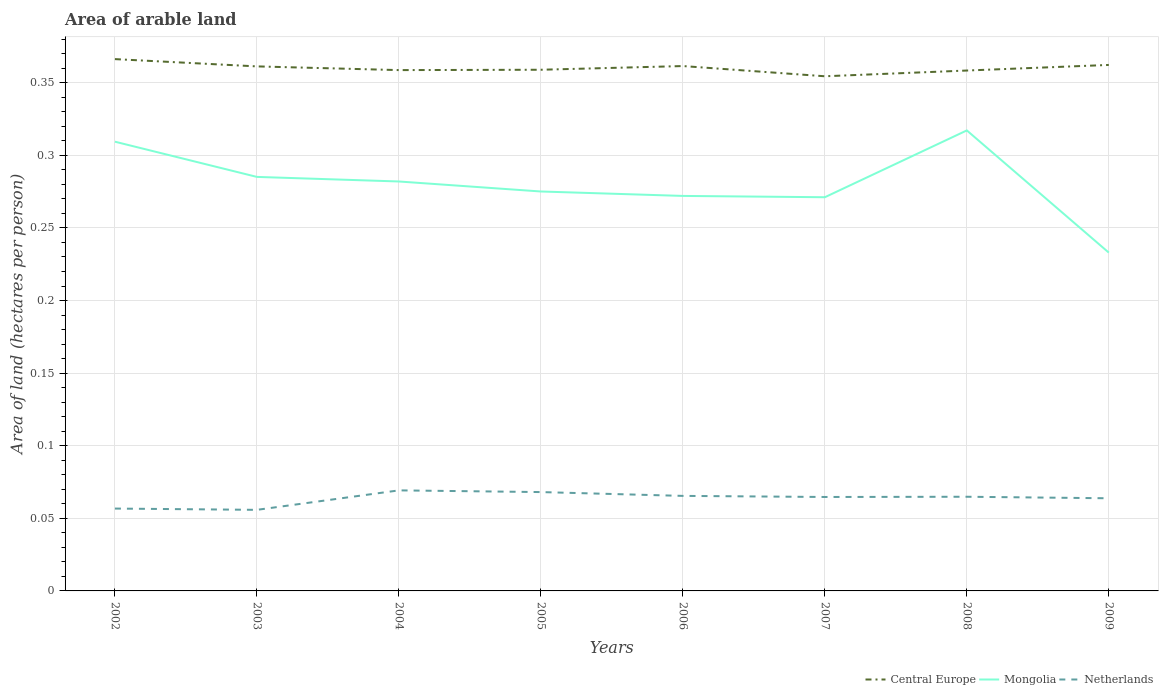How many different coloured lines are there?
Your answer should be very brief. 3. Does the line corresponding to Netherlands intersect with the line corresponding to Central Europe?
Ensure brevity in your answer.  No. Is the number of lines equal to the number of legend labels?
Offer a terse response. Yes. Across all years, what is the maximum total arable land in Central Europe?
Give a very brief answer. 0.35. What is the total total arable land in Netherlands in the graph?
Keep it short and to the point. 0. What is the difference between the highest and the second highest total arable land in Netherlands?
Ensure brevity in your answer.  0.01. What is the difference between the highest and the lowest total arable land in Central Europe?
Provide a short and direct response. 4. How many lines are there?
Offer a terse response. 3. How many years are there in the graph?
Your response must be concise. 8. Are the values on the major ticks of Y-axis written in scientific E-notation?
Give a very brief answer. No. Does the graph contain grids?
Give a very brief answer. Yes. Where does the legend appear in the graph?
Offer a terse response. Bottom right. How are the legend labels stacked?
Keep it short and to the point. Horizontal. What is the title of the graph?
Your answer should be compact. Area of arable land. What is the label or title of the X-axis?
Provide a short and direct response. Years. What is the label or title of the Y-axis?
Give a very brief answer. Area of land (hectares per person). What is the Area of land (hectares per person) of Central Europe in 2002?
Your answer should be compact. 0.37. What is the Area of land (hectares per person) of Mongolia in 2002?
Provide a short and direct response. 0.31. What is the Area of land (hectares per person) in Netherlands in 2002?
Provide a short and direct response. 0.06. What is the Area of land (hectares per person) of Central Europe in 2003?
Offer a very short reply. 0.36. What is the Area of land (hectares per person) of Mongolia in 2003?
Offer a very short reply. 0.29. What is the Area of land (hectares per person) in Netherlands in 2003?
Offer a very short reply. 0.06. What is the Area of land (hectares per person) in Central Europe in 2004?
Your answer should be very brief. 0.36. What is the Area of land (hectares per person) of Mongolia in 2004?
Offer a terse response. 0.28. What is the Area of land (hectares per person) of Netherlands in 2004?
Give a very brief answer. 0.07. What is the Area of land (hectares per person) in Central Europe in 2005?
Provide a short and direct response. 0.36. What is the Area of land (hectares per person) of Mongolia in 2005?
Offer a very short reply. 0.28. What is the Area of land (hectares per person) in Netherlands in 2005?
Offer a very short reply. 0.07. What is the Area of land (hectares per person) in Central Europe in 2006?
Make the answer very short. 0.36. What is the Area of land (hectares per person) of Mongolia in 2006?
Give a very brief answer. 0.27. What is the Area of land (hectares per person) of Netherlands in 2006?
Ensure brevity in your answer.  0.07. What is the Area of land (hectares per person) in Central Europe in 2007?
Offer a terse response. 0.35. What is the Area of land (hectares per person) in Mongolia in 2007?
Give a very brief answer. 0.27. What is the Area of land (hectares per person) of Netherlands in 2007?
Offer a terse response. 0.06. What is the Area of land (hectares per person) of Central Europe in 2008?
Make the answer very short. 0.36. What is the Area of land (hectares per person) of Mongolia in 2008?
Your response must be concise. 0.32. What is the Area of land (hectares per person) in Netherlands in 2008?
Keep it short and to the point. 0.06. What is the Area of land (hectares per person) in Central Europe in 2009?
Your response must be concise. 0.36. What is the Area of land (hectares per person) of Mongolia in 2009?
Your response must be concise. 0.23. What is the Area of land (hectares per person) of Netherlands in 2009?
Give a very brief answer. 0.06. Across all years, what is the maximum Area of land (hectares per person) in Central Europe?
Keep it short and to the point. 0.37. Across all years, what is the maximum Area of land (hectares per person) in Mongolia?
Offer a terse response. 0.32. Across all years, what is the maximum Area of land (hectares per person) in Netherlands?
Provide a succinct answer. 0.07. Across all years, what is the minimum Area of land (hectares per person) in Central Europe?
Your answer should be very brief. 0.35. Across all years, what is the minimum Area of land (hectares per person) of Mongolia?
Ensure brevity in your answer.  0.23. Across all years, what is the minimum Area of land (hectares per person) of Netherlands?
Make the answer very short. 0.06. What is the total Area of land (hectares per person) of Central Europe in the graph?
Provide a succinct answer. 2.88. What is the total Area of land (hectares per person) in Mongolia in the graph?
Your answer should be very brief. 2.24. What is the total Area of land (hectares per person) of Netherlands in the graph?
Your answer should be compact. 0.51. What is the difference between the Area of land (hectares per person) in Central Europe in 2002 and that in 2003?
Offer a terse response. 0.01. What is the difference between the Area of land (hectares per person) of Mongolia in 2002 and that in 2003?
Offer a terse response. 0.02. What is the difference between the Area of land (hectares per person) of Netherlands in 2002 and that in 2003?
Your response must be concise. 0. What is the difference between the Area of land (hectares per person) of Central Europe in 2002 and that in 2004?
Give a very brief answer. 0.01. What is the difference between the Area of land (hectares per person) of Mongolia in 2002 and that in 2004?
Offer a very short reply. 0.03. What is the difference between the Area of land (hectares per person) of Netherlands in 2002 and that in 2004?
Ensure brevity in your answer.  -0.01. What is the difference between the Area of land (hectares per person) of Central Europe in 2002 and that in 2005?
Your answer should be compact. 0.01. What is the difference between the Area of land (hectares per person) in Mongolia in 2002 and that in 2005?
Provide a short and direct response. 0.03. What is the difference between the Area of land (hectares per person) of Netherlands in 2002 and that in 2005?
Make the answer very short. -0.01. What is the difference between the Area of land (hectares per person) in Central Europe in 2002 and that in 2006?
Ensure brevity in your answer.  0. What is the difference between the Area of land (hectares per person) of Mongolia in 2002 and that in 2006?
Your answer should be very brief. 0.04. What is the difference between the Area of land (hectares per person) in Netherlands in 2002 and that in 2006?
Give a very brief answer. -0.01. What is the difference between the Area of land (hectares per person) in Central Europe in 2002 and that in 2007?
Your answer should be compact. 0.01. What is the difference between the Area of land (hectares per person) of Mongolia in 2002 and that in 2007?
Provide a succinct answer. 0.04. What is the difference between the Area of land (hectares per person) in Netherlands in 2002 and that in 2007?
Your answer should be very brief. -0.01. What is the difference between the Area of land (hectares per person) of Central Europe in 2002 and that in 2008?
Your response must be concise. 0.01. What is the difference between the Area of land (hectares per person) in Mongolia in 2002 and that in 2008?
Offer a very short reply. -0.01. What is the difference between the Area of land (hectares per person) in Netherlands in 2002 and that in 2008?
Offer a very short reply. -0.01. What is the difference between the Area of land (hectares per person) of Central Europe in 2002 and that in 2009?
Your answer should be very brief. 0. What is the difference between the Area of land (hectares per person) in Mongolia in 2002 and that in 2009?
Your answer should be very brief. 0.08. What is the difference between the Area of land (hectares per person) in Netherlands in 2002 and that in 2009?
Make the answer very short. -0.01. What is the difference between the Area of land (hectares per person) in Central Europe in 2003 and that in 2004?
Your answer should be very brief. 0. What is the difference between the Area of land (hectares per person) in Mongolia in 2003 and that in 2004?
Give a very brief answer. 0. What is the difference between the Area of land (hectares per person) of Netherlands in 2003 and that in 2004?
Offer a very short reply. -0.01. What is the difference between the Area of land (hectares per person) in Central Europe in 2003 and that in 2005?
Offer a very short reply. 0. What is the difference between the Area of land (hectares per person) in Mongolia in 2003 and that in 2005?
Give a very brief answer. 0.01. What is the difference between the Area of land (hectares per person) in Netherlands in 2003 and that in 2005?
Give a very brief answer. -0.01. What is the difference between the Area of land (hectares per person) in Central Europe in 2003 and that in 2006?
Offer a terse response. -0. What is the difference between the Area of land (hectares per person) in Mongolia in 2003 and that in 2006?
Your answer should be very brief. 0.01. What is the difference between the Area of land (hectares per person) of Netherlands in 2003 and that in 2006?
Provide a short and direct response. -0.01. What is the difference between the Area of land (hectares per person) of Central Europe in 2003 and that in 2007?
Make the answer very short. 0.01. What is the difference between the Area of land (hectares per person) of Mongolia in 2003 and that in 2007?
Make the answer very short. 0.01. What is the difference between the Area of land (hectares per person) in Netherlands in 2003 and that in 2007?
Provide a short and direct response. -0.01. What is the difference between the Area of land (hectares per person) of Central Europe in 2003 and that in 2008?
Provide a succinct answer. 0. What is the difference between the Area of land (hectares per person) in Mongolia in 2003 and that in 2008?
Your response must be concise. -0.03. What is the difference between the Area of land (hectares per person) of Netherlands in 2003 and that in 2008?
Give a very brief answer. -0.01. What is the difference between the Area of land (hectares per person) in Central Europe in 2003 and that in 2009?
Offer a terse response. -0. What is the difference between the Area of land (hectares per person) in Mongolia in 2003 and that in 2009?
Give a very brief answer. 0.05. What is the difference between the Area of land (hectares per person) in Netherlands in 2003 and that in 2009?
Provide a succinct answer. -0.01. What is the difference between the Area of land (hectares per person) in Central Europe in 2004 and that in 2005?
Provide a short and direct response. -0. What is the difference between the Area of land (hectares per person) of Mongolia in 2004 and that in 2005?
Give a very brief answer. 0.01. What is the difference between the Area of land (hectares per person) in Netherlands in 2004 and that in 2005?
Provide a short and direct response. 0. What is the difference between the Area of land (hectares per person) in Central Europe in 2004 and that in 2006?
Your response must be concise. -0. What is the difference between the Area of land (hectares per person) of Mongolia in 2004 and that in 2006?
Provide a short and direct response. 0.01. What is the difference between the Area of land (hectares per person) of Netherlands in 2004 and that in 2006?
Keep it short and to the point. 0. What is the difference between the Area of land (hectares per person) of Central Europe in 2004 and that in 2007?
Your answer should be compact. 0. What is the difference between the Area of land (hectares per person) in Mongolia in 2004 and that in 2007?
Your response must be concise. 0.01. What is the difference between the Area of land (hectares per person) of Netherlands in 2004 and that in 2007?
Your answer should be compact. 0. What is the difference between the Area of land (hectares per person) of Central Europe in 2004 and that in 2008?
Offer a terse response. 0. What is the difference between the Area of land (hectares per person) in Mongolia in 2004 and that in 2008?
Give a very brief answer. -0.04. What is the difference between the Area of land (hectares per person) of Netherlands in 2004 and that in 2008?
Your response must be concise. 0. What is the difference between the Area of land (hectares per person) of Central Europe in 2004 and that in 2009?
Your response must be concise. -0. What is the difference between the Area of land (hectares per person) in Mongolia in 2004 and that in 2009?
Offer a very short reply. 0.05. What is the difference between the Area of land (hectares per person) in Netherlands in 2004 and that in 2009?
Your answer should be compact. 0.01. What is the difference between the Area of land (hectares per person) in Central Europe in 2005 and that in 2006?
Ensure brevity in your answer.  -0. What is the difference between the Area of land (hectares per person) in Mongolia in 2005 and that in 2006?
Provide a succinct answer. 0. What is the difference between the Area of land (hectares per person) of Netherlands in 2005 and that in 2006?
Keep it short and to the point. 0. What is the difference between the Area of land (hectares per person) in Central Europe in 2005 and that in 2007?
Your response must be concise. 0. What is the difference between the Area of land (hectares per person) of Mongolia in 2005 and that in 2007?
Keep it short and to the point. 0. What is the difference between the Area of land (hectares per person) in Netherlands in 2005 and that in 2007?
Give a very brief answer. 0. What is the difference between the Area of land (hectares per person) of Mongolia in 2005 and that in 2008?
Keep it short and to the point. -0.04. What is the difference between the Area of land (hectares per person) in Netherlands in 2005 and that in 2008?
Your response must be concise. 0. What is the difference between the Area of land (hectares per person) of Central Europe in 2005 and that in 2009?
Offer a terse response. -0. What is the difference between the Area of land (hectares per person) of Mongolia in 2005 and that in 2009?
Offer a terse response. 0.04. What is the difference between the Area of land (hectares per person) of Netherlands in 2005 and that in 2009?
Give a very brief answer. 0. What is the difference between the Area of land (hectares per person) in Central Europe in 2006 and that in 2007?
Give a very brief answer. 0.01. What is the difference between the Area of land (hectares per person) of Mongolia in 2006 and that in 2007?
Provide a short and direct response. 0. What is the difference between the Area of land (hectares per person) in Netherlands in 2006 and that in 2007?
Your answer should be compact. 0. What is the difference between the Area of land (hectares per person) of Central Europe in 2006 and that in 2008?
Give a very brief answer. 0. What is the difference between the Area of land (hectares per person) of Mongolia in 2006 and that in 2008?
Provide a short and direct response. -0.05. What is the difference between the Area of land (hectares per person) of Netherlands in 2006 and that in 2008?
Provide a succinct answer. 0. What is the difference between the Area of land (hectares per person) of Central Europe in 2006 and that in 2009?
Keep it short and to the point. -0. What is the difference between the Area of land (hectares per person) in Mongolia in 2006 and that in 2009?
Ensure brevity in your answer.  0.04. What is the difference between the Area of land (hectares per person) in Netherlands in 2006 and that in 2009?
Give a very brief answer. 0. What is the difference between the Area of land (hectares per person) of Central Europe in 2007 and that in 2008?
Your answer should be compact. -0. What is the difference between the Area of land (hectares per person) of Mongolia in 2007 and that in 2008?
Ensure brevity in your answer.  -0.05. What is the difference between the Area of land (hectares per person) in Netherlands in 2007 and that in 2008?
Keep it short and to the point. -0. What is the difference between the Area of land (hectares per person) of Central Europe in 2007 and that in 2009?
Offer a very short reply. -0.01. What is the difference between the Area of land (hectares per person) of Mongolia in 2007 and that in 2009?
Keep it short and to the point. 0.04. What is the difference between the Area of land (hectares per person) of Netherlands in 2007 and that in 2009?
Your answer should be compact. 0. What is the difference between the Area of land (hectares per person) in Central Europe in 2008 and that in 2009?
Your answer should be compact. -0. What is the difference between the Area of land (hectares per person) in Mongolia in 2008 and that in 2009?
Give a very brief answer. 0.08. What is the difference between the Area of land (hectares per person) in Netherlands in 2008 and that in 2009?
Offer a very short reply. 0. What is the difference between the Area of land (hectares per person) in Central Europe in 2002 and the Area of land (hectares per person) in Mongolia in 2003?
Provide a short and direct response. 0.08. What is the difference between the Area of land (hectares per person) of Central Europe in 2002 and the Area of land (hectares per person) of Netherlands in 2003?
Offer a terse response. 0.31. What is the difference between the Area of land (hectares per person) in Mongolia in 2002 and the Area of land (hectares per person) in Netherlands in 2003?
Your answer should be compact. 0.25. What is the difference between the Area of land (hectares per person) in Central Europe in 2002 and the Area of land (hectares per person) in Mongolia in 2004?
Make the answer very short. 0.08. What is the difference between the Area of land (hectares per person) of Central Europe in 2002 and the Area of land (hectares per person) of Netherlands in 2004?
Ensure brevity in your answer.  0.3. What is the difference between the Area of land (hectares per person) in Mongolia in 2002 and the Area of land (hectares per person) in Netherlands in 2004?
Keep it short and to the point. 0.24. What is the difference between the Area of land (hectares per person) in Central Europe in 2002 and the Area of land (hectares per person) in Mongolia in 2005?
Your response must be concise. 0.09. What is the difference between the Area of land (hectares per person) of Central Europe in 2002 and the Area of land (hectares per person) of Netherlands in 2005?
Your answer should be compact. 0.3. What is the difference between the Area of land (hectares per person) of Mongolia in 2002 and the Area of land (hectares per person) of Netherlands in 2005?
Provide a succinct answer. 0.24. What is the difference between the Area of land (hectares per person) in Central Europe in 2002 and the Area of land (hectares per person) in Mongolia in 2006?
Offer a very short reply. 0.09. What is the difference between the Area of land (hectares per person) in Central Europe in 2002 and the Area of land (hectares per person) in Netherlands in 2006?
Provide a succinct answer. 0.3. What is the difference between the Area of land (hectares per person) of Mongolia in 2002 and the Area of land (hectares per person) of Netherlands in 2006?
Offer a terse response. 0.24. What is the difference between the Area of land (hectares per person) of Central Europe in 2002 and the Area of land (hectares per person) of Mongolia in 2007?
Offer a terse response. 0.1. What is the difference between the Area of land (hectares per person) in Central Europe in 2002 and the Area of land (hectares per person) in Netherlands in 2007?
Offer a very short reply. 0.3. What is the difference between the Area of land (hectares per person) in Mongolia in 2002 and the Area of land (hectares per person) in Netherlands in 2007?
Ensure brevity in your answer.  0.24. What is the difference between the Area of land (hectares per person) of Central Europe in 2002 and the Area of land (hectares per person) of Mongolia in 2008?
Keep it short and to the point. 0.05. What is the difference between the Area of land (hectares per person) in Central Europe in 2002 and the Area of land (hectares per person) in Netherlands in 2008?
Keep it short and to the point. 0.3. What is the difference between the Area of land (hectares per person) of Mongolia in 2002 and the Area of land (hectares per person) of Netherlands in 2008?
Offer a very short reply. 0.24. What is the difference between the Area of land (hectares per person) in Central Europe in 2002 and the Area of land (hectares per person) in Mongolia in 2009?
Offer a terse response. 0.13. What is the difference between the Area of land (hectares per person) in Central Europe in 2002 and the Area of land (hectares per person) in Netherlands in 2009?
Keep it short and to the point. 0.3. What is the difference between the Area of land (hectares per person) in Mongolia in 2002 and the Area of land (hectares per person) in Netherlands in 2009?
Provide a succinct answer. 0.25. What is the difference between the Area of land (hectares per person) in Central Europe in 2003 and the Area of land (hectares per person) in Mongolia in 2004?
Give a very brief answer. 0.08. What is the difference between the Area of land (hectares per person) of Central Europe in 2003 and the Area of land (hectares per person) of Netherlands in 2004?
Offer a terse response. 0.29. What is the difference between the Area of land (hectares per person) of Mongolia in 2003 and the Area of land (hectares per person) of Netherlands in 2004?
Offer a terse response. 0.22. What is the difference between the Area of land (hectares per person) in Central Europe in 2003 and the Area of land (hectares per person) in Mongolia in 2005?
Keep it short and to the point. 0.09. What is the difference between the Area of land (hectares per person) in Central Europe in 2003 and the Area of land (hectares per person) in Netherlands in 2005?
Keep it short and to the point. 0.29. What is the difference between the Area of land (hectares per person) in Mongolia in 2003 and the Area of land (hectares per person) in Netherlands in 2005?
Make the answer very short. 0.22. What is the difference between the Area of land (hectares per person) of Central Europe in 2003 and the Area of land (hectares per person) of Mongolia in 2006?
Your answer should be compact. 0.09. What is the difference between the Area of land (hectares per person) of Central Europe in 2003 and the Area of land (hectares per person) of Netherlands in 2006?
Keep it short and to the point. 0.3. What is the difference between the Area of land (hectares per person) of Mongolia in 2003 and the Area of land (hectares per person) of Netherlands in 2006?
Your answer should be very brief. 0.22. What is the difference between the Area of land (hectares per person) of Central Europe in 2003 and the Area of land (hectares per person) of Mongolia in 2007?
Your answer should be compact. 0.09. What is the difference between the Area of land (hectares per person) of Central Europe in 2003 and the Area of land (hectares per person) of Netherlands in 2007?
Ensure brevity in your answer.  0.3. What is the difference between the Area of land (hectares per person) of Mongolia in 2003 and the Area of land (hectares per person) of Netherlands in 2007?
Your answer should be compact. 0.22. What is the difference between the Area of land (hectares per person) in Central Europe in 2003 and the Area of land (hectares per person) in Mongolia in 2008?
Offer a very short reply. 0.04. What is the difference between the Area of land (hectares per person) in Central Europe in 2003 and the Area of land (hectares per person) in Netherlands in 2008?
Provide a succinct answer. 0.3. What is the difference between the Area of land (hectares per person) in Mongolia in 2003 and the Area of land (hectares per person) in Netherlands in 2008?
Give a very brief answer. 0.22. What is the difference between the Area of land (hectares per person) of Central Europe in 2003 and the Area of land (hectares per person) of Mongolia in 2009?
Your answer should be compact. 0.13. What is the difference between the Area of land (hectares per person) of Central Europe in 2003 and the Area of land (hectares per person) of Netherlands in 2009?
Give a very brief answer. 0.3. What is the difference between the Area of land (hectares per person) in Mongolia in 2003 and the Area of land (hectares per person) in Netherlands in 2009?
Give a very brief answer. 0.22. What is the difference between the Area of land (hectares per person) in Central Europe in 2004 and the Area of land (hectares per person) in Mongolia in 2005?
Provide a succinct answer. 0.08. What is the difference between the Area of land (hectares per person) of Central Europe in 2004 and the Area of land (hectares per person) of Netherlands in 2005?
Make the answer very short. 0.29. What is the difference between the Area of land (hectares per person) of Mongolia in 2004 and the Area of land (hectares per person) of Netherlands in 2005?
Offer a very short reply. 0.21. What is the difference between the Area of land (hectares per person) in Central Europe in 2004 and the Area of land (hectares per person) in Mongolia in 2006?
Offer a very short reply. 0.09. What is the difference between the Area of land (hectares per person) of Central Europe in 2004 and the Area of land (hectares per person) of Netherlands in 2006?
Provide a succinct answer. 0.29. What is the difference between the Area of land (hectares per person) in Mongolia in 2004 and the Area of land (hectares per person) in Netherlands in 2006?
Provide a succinct answer. 0.22. What is the difference between the Area of land (hectares per person) in Central Europe in 2004 and the Area of land (hectares per person) in Mongolia in 2007?
Keep it short and to the point. 0.09. What is the difference between the Area of land (hectares per person) in Central Europe in 2004 and the Area of land (hectares per person) in Netherlands in 2007?
Ensure brevity in your answer.  0.29. What is the difference between the Area of land (hectares per person) in Mongolia in 2004 and the Area of land (hectares per person) in Netherlands in 2007?
Ensure brevity in your answer.  0.22. What is the difference between the Area of land (hectares per person) in Central Europe in 2004 and the Area of land (hectares per person) in Mongolia in 2008?
Provide a short and direct response. 0.04. What is the difference between the Area of land (hectares per person) in Central Europe in 2004 and the Area of land (hectares per person) in Netherlands in 2008?
Keep it short and to the point. 0.29. What is the difference between the Area of land (hectares per person) of Mongolia in 2004 and the Area of land (hectares per person) of Netherlands in 2008?
Make the answer very short. 0.22. What is the difference between the Area of land (hectares per person) in Central Europe in 2004 and the Area of land (hectares per person) in Mongolia in 2009?
Give a very brief answer. 0.13. What is the difference between the Area of land (hectares per person) in Central Europe in 2004 and the Area of land (hectares per person) in Netherlands in 2009?
Provide a short and direct response. 0.29. What is the difference between the Area of land (hectares per person) of Mongolia in 2004 and the Area of land (hectares per person) of Netherlands in 2009?
Your answer should be compact. 0.22. What is the difference between the Area of land (hectares per person) in Central Europe in 2005 and the Area of land (hectares per person) in Mongolia in 2006?
Give a very brief answer. 0.09. What is the difference between the Area of land (hectares per person) of Central Europe in 2005 and the Area of land (hectares per person) of Netherlands in 2006?
Make the answer very short. 0.29. What is the difference between the Area of land (hectares per person) in Mongolia in 2005 and the Area of land (hectares per person) in Netherlands in 2006?
Make the answer very short. 0.21. What is the difference between the Area of land (hectares per person) in Central Europe in 2005 and the Area of land (hectares per person) in Mongolia in 2007?
Your answer should be very brief. 0.09. What is the difference between the Area of land (hectares per person) of Central Europe in 2005 and the Area of land (hectares per person) of Netherlands in 2007?
Your answer should be very brief. 0.29. What is the difference between the Area of land (hectares per person) of Mongolia in 2005 and the Area of land (hectares per person) of Netherlands in 2007?
Offer a very short reply. 0.21. What is the difference between the Area of land (hectares per person) of Central Europe in 2005 and the Area of land (hectares per person) of Mongolia in 2008?
Your answer should be very brief. 0.04. What is the difference between the Area of land (hectares per person) in Central Europe in 2005 and the Area of land (hectares per person) in Netherlands in 2008?
Provide a short and direct response. 0.29. What is the difference between the Area of land (hectares per person) of Mongolia in 2005 and the Area of land (hectares per person) of Netherlands in 2008?
Provide a short and direct response. 0.21. What is the difference between the Area of land (hectares per person) in Central Europe in 2005 and the Area of land (hectares per person) in Mongolia in 2009?
Offer a terse response. 0.13. What is the difference between the Area of land (hectares per person) of Central Europe in 2005 and the Area of land (hectares per person) of Netherlands in 2009?
Offer a very short reply. 0.3. What is the difference between the Area of land (hectares per person) in Mongolia in 2005 and the Area of land (hectares per person) in Netherlands in 2009?
Your answer should be very brief. 0.21. What is the difference between the Area of land (hectares per person) of Central Europe in 2006 and the Area of land (hectares per person) of Mongolia in 2007?
Provide a short and direct response. 0.09. What is the difference between the Area of land (hectares per person) of Central Europe in 2006 and the Area of land (hectares per person) of Netherlands in 2007?
Your response must be concise. 0.3. What is the difference between the Area of land (hectares per person) of Mongolia in 2006 and the Area of land (hectares per person) of Netherlands in 2007?
Give a very brief answer. 0.21. What is the difference between the Area of land (hectares per person) in Central Europe in 2006 and the Area of land (hectares per person) in Mongolia in 2008?
Your answer should be compact. 0.04. What is the difference between the Area of land (hectares per person) in Central Europe in 2006 and the Area of land (hectares per person) in Netherlands in 2008?
Provide a short and direct response. 0.3. What is the difference between the Area of land (hectares per person) of Mongolia in 2006 and the Area of land (hectares per person) of Netherlands in 2008?
Provide a succinct answer. 0.21. What is the difference between the Area of land (hectares per person) in Central Europe in 2006 and the Area of land (hectares per person) in Mongolia in 2009?
Provide a short and direct response. 0.13. What is the difference between the Area of land (hectares per person) of Central Europe in 2006 and the Area of land (hectares per person) of Netherlands in 2009?
Your answer should be compact. 0.3. What is the difference between the Area of land (hectares per person) of Mongolia in 2006 and the Area of land (hectares per person) of Netherlands in 2009?
Provide a succinct answer. 0.21. What is the difference between the Area of land (hectares per person) in Central Europe in 2007 and the Area of land (hectares per person) in Mongolia in 2008?
Provide a succinct answer. 0.04. What is the difference between the Area of land (hectares per person) in Central Europe in 2007 and the Area of land (hectares per person) in Netherlands in 2008?
Give a very brief answer. 0.29. What is the difference between the Area of land (hectares per person) of Mongolia in 2007 and the Area of land (hectares per person) of Netherlands in 2008?
Your answer should be very brief. 0.21. What is the difference between the Area of land (hectares per person) of Central Europe in 2007 and the Area of land (hectares per person) of Mongolia in 2009?
Keep it short and to the point. 0.12. What is the difference between the Area of land (hectares per person) in Central Europe in 2007 and the Area of land (hectares per person) in Netherlands in 2009?
Ensure brevity in your answer.  0.29. What is the difference between the Area of land (hectares per person) of Mongolia in 2007 and the Area of land (hectares per person) of Netherlands in 2009?
Your answer should be very brief. 0.21. What is the difference between the Area of land (hectares per person) in Central Europe in 2008 and the Area of land (hectares per person) in Mongolia in 2009?
Ensure brevity in your answer.  0.13. What is the difference between the Area of land (hectares per person) of Central Europe in 2008 and the Area of land (hectares per person) of Netherlands in 2009?
Your answer should be very brief. 0.29. What is the difference between the Area of land (hectares per person) of Mongolia in 2008 and the Area of land (hectares per person) of Netherlands in 2009?
Offer a terse response. 0.25. What is the average Area of land (hectares per person) of Central Europe per year?
Your answer should be very brief. 0.36. What is the average Area of land (hectares per person) of Mongolia per year?
Your response must be concise. 0.28. What is the average Area of land (hectares per person) in Netherlands per year?
Keep it short and to the point. 0.06. In the year 2002, what is the difference between the Area of land (hectares per person) of Central Europe and Area of land (hectares per person) of Mongolia?
Your answer should be very brief. 0.06. In the year 2002, what is the difference between the Area of land (hectares per person) of Central Europe and Area of land (hectares per person) of Netherlands?
Make the answer very short. 0.31. In the year 2002, what is the difference between the Area of land (hectares per person) in Mongolia and Area of land (hectares per person) in Netherlands?
Make the answer very short. 0.25. In the year 2003, what is the difference between the Area of land (hectares per person) in Central Europe and Area of land (hectares per person) in Mongolia?
Offer a very short reply. 0.08. In the year 2003, what is the difference between the Area of land (hectares per person) in Central Europe and Area of land (hectares per person) in Netherlands?
Ensure brevity in your answer.  0.31. In the year 2003, what is the difference between the Area of land (hectares per person) of Mongolia and Area of land (hectares per person) of Netherlands?
Make the answer very short. 0.23. In the year 2004, what is the difference between the Area of land (hectares per person) of Central Europe and Area of land (hectares per person) of Mongolia?
Provide a succinct answer. 0.08. In the year 2004, what is the difference between the Area of land (hectares per person) of Central Europe and Area of land (hectares per person) of Netherlands?
Your answer should be very brief. 0.29. In the year 2004, what is the difference between the Area of land (hectares per person) of Mongolia and Area of land (hectares per person) of Netherlands?
Ensure brevity in your answer.  0.21. In the year 2005, what is the difference between the Area of land (hectares per person) of Central Europe and Area of land (hectares per person) of Mongolia?
Keep it short and to the point. 0.08. In the year 2005, what is the difference between the Area of land (hectares per person) of Central Europe and Area of land (hectares per person) of Netherlands?
Your response must be concise. 0.29. In the year 2005, what is the difference between the Area of land (hectares per person) in Mongolia and Area of land (hectares per person) in Netherlands?
Your answer should be compact. 0.21. In the year 2006, what is the difference between the Area of land (hectares per person) of Central Europe and Area of land (hectares per person) of Mongolia?
Offer a very short reply. 0.09. In the year 2006, what is the difference between the Area of land (hectares per person) in Central Europe and Area of land (hectares per person) in Netherlands?
Offer a terse response. 0.3. In the year 2006, what is the difference between the Area of land (hectares per person) of Mongolia and Area of land (hectares per person) of Netherlands?
Provide a short and direct response. 0.21. In the year 2007, what is the difference between the Area of land (hectares per person) in Central Europe and Area of land (hectares per person) in Mongolia?
Offer a terse response. 0.08. In the year 2007, what is the difference between the Area of land (hectares per person) in Central Europe and Area of land (hectares per person) in Netherlands?
Your response must be concise. 0.29. In the year 2007, what is the difference between the Area of land (hectares per person) in Mongolia and Area of land (hectares per person) in Netherlands?
Offer a terse response. 0.21. In the year 2008, what is the difference between the Area of land (hectares per person) of Central Europe and Area of land (hectares per person) of Mongolia?
Ensure brevity in your answer.  0.04. In the year 2008, what is the difference between the Area of land (hectares per person) in Central Europe and Area of land (hectares per person) in Netherlands?
Offer a terse response. 0.29. In the year 2008, what is the difference between the Area of land (hectares per person) of Mongolia and Area of land (hectares per person) of Netherlands?
Ensure brevity in your answer.  0.25. In the year 2009, what is the difference between the Area of land (hectares per person) in Central Europe and Area of land (hectares per person) in Mongolia?
Provide a succinct answer. 0.13. In the year 2009, what is the difference between the Area of land (hectares per person) of Central Europe and Area of land (hectares per person) of Netherlands?
Ensure brevity in your answer.  0.3. In the year 2009, what is the difference between the Area of land (hectares per person) of Mongolia and Area of land (hectares per person) of Netherlands?
Provide a short and direct response. 0.17. What is the ratio of the Area of land (hectares per person) in Central Europe in 2002 to that in 2003?
Your answer should be very brief. 1.01. What is the ratio of the Area of land (hectares per person) of Mongolia in 2002 to that in 2003?
Your response must be concise. 1.09. What is the ratio of the Area of land (hectares per person) in Netherlands in 2002 to that in 2003?
Your answer should be compact. 1.02. What is the ratio of the Area of land (hectares per person) in Central Europe in 2002 to that in 2004?
Ensure brevity in your answer.  1.02. What is the ratio of the Area of land (hectares per person) of Mongolia in 2002 to that in 2004?
Provide a succinct answer. 1.1. What is the ratio of the Area of land (hectares per person) of Netherlands in 2002 to that in 2004?
Offer a very short reply. 0.82. What is the ratio of the Area of land (hectares per person) of Central Europe in 2002 to that in 2005?
Your response must be concise. 1.02. What is the ratio of the Area of land (hectares per person) of Mongolia in 2002 to that in 2005?
Your response must be concise. 1.12. What is the ratio of the Area of land (hectares per person) of Netherlands in 2002 to that in 2005?
Keep it short and to the point. 0.83. What is the ratio of the Area of land (hectares per person) in Central Europe in 2002 to that in 2006?
Make the answer very short. 1.01. What is the ratio of the Area of land (hectares per person) of Mongolia in 2002 to that in 2006?
Make the answer very short. 1.14. What is the ratio of the Area of land (hectares per person) in Netherlands in 2002 to that in 2006?
Offer a terse response. 0.87. What is the ratio of the Area of land (hectares per person) of Mongolia in 2002 to that in 2007?
Offer a very short reply. 1.14. What is the ratio of the Area of land (hectares per person) in Netherlands in 2002 to that in 2007?
Keep it short and to the point. 0.88. What is the ratio of the Area of land (hectares per person) of Central Europe in 2002 to that in 2008?
Ensure brevity in your answer.  1.02. What is the ratio of the Area of land (hectares per person) of Mongolia in 2002 to that in 2008?
Provide a succinct answer. 0.98. What is the ratio of the Area of land (hectares per person) of Netherlands in 2002 to that in 2008?
Offer a very short reply. 0.87. What is the ratio of the Area of land (hectares per person) of Central Europe in 2002 to that in 2009?
Your response must be concise. 1.01. What is the ratio of the Area of land (hectares per person) of Mongolia in 2002 to that in 2009?
Your answer should be compact. 1.33. What is the ratio of the Area of land (hectares per person) in Netherlands in 2002 to that in 2009?
Your response must be concise. 0.89. What is the ratio of the Area of land (hectares per person) in Central Europe in 2003 to that in 2004?
Your response must be concise. 1.01. What is the ratio of the Area of land (hectares per person) of Mongolia in 2003 to that in 2004?
Keep it short and to the point. 1.01. What is the ratio of the Area of land (hectares per person) of Netherlands in 2003 to that in 2004?
Your response must be concise. 0.81. What is the ratio of the Area of land (hectares per person) of Central Europe in 2003 to that in 2005?
Your answer should be compact. 1.01. What is the ratio of the Area of land (hectares per person) of Mongolia in 2003 to that in 2005?
Make the answer very short. 1.04. What is the ratio of the Area of land (hectares per person) in Netherlands in 2003 to that in 2005?
Your answer should be very brief. 0.82. What is the ratio of the Area of land (hectares per person) of Mongolia in 2003 to that in 2006?
Ensure brevity in your answer.  1.05. What is the ratio of the Area of land (hectares per person) in Netherlands in 2003 to that in 2006?
Offer a terse response. 0.85. What is the ratio of the Area of land (hectares per person) of Central Europe in 2003 to that in 2007?
Ensure brevity in your answer.  1.02. What is the ratio of the Area of land (hectares per person) of Mongolia in 2003 to that in 2007?
Offer a terse response. 1.05. What is the ratio of the Area of land (hectares per person) of Netherlands in 2003 to that in 2007?
Provide a succinct answer. 0.86. What is the ratio of the Area of land (hectares per person) of Central Europe in 2003 to that in 2008?
Offer a terse response. 1.01. What is the ratio of the Area of land (hectares per person) of Mongolia in 2003 to that in 2008?
Provide a succinct answer. 0.9. What is the ratio of the Area of land (hectares per person) of Netherlands in 2003 to that in 2008?
Ensure brevity in your answer.  0.86. What is the ratio of the Area of land (hectares per person) of Mongolia in 2003 to that in 2009?
Make the answer very short. 1.22. What is the ratio of the Area of land (hectares per person) of Netherlands in 2003 to that in 2009?
Provide a short and direct response. 0.88. What is the ratio of the Area of land (hectares per person) of Mongolia in 2004 to that in 2005?
Your answer should be compact. 1.03. What is the ratio of the Area of land (hectares per person) in Netherlands in 2004 to that in 2005?
Give a very brief answer. 1.02. What is the ratio of the Area of land (hectares per person) in Mongolia in 2004 to that in 2006?
Provide a short and direct response. 1.04. What is the ratio of the Area of land (hectares per person) in Netherlands in 2004 to that in 2006?
Provide a short and direct response. 1.06. What is the ratio of the Area of land (hectares per person) of Mongolia in 2004 to that in 2007?
Ensure brevity in your answer.  1.04. What is the ratio of the Area of land (hectares per person) in Netherlands in 2004 to that in 2007?
Your answer should be very brief. 1.07. What is the ratio of the Area of land (hectares per person) in Mongolia in 2004 to that in 2008?
Give a very brief answer. 0.89. What is the ratio of the Area of land (hectares per person) of Netherlands in 2004 to that in 2008?
Offer a very short reply. 1.07. What is the ratio of the Area of land (hectares per person) in Central Europe in 2004 to that in 2009?
Provide a short and direct response. 0.99. What is the ratio of the Area of land (hectares per person) of Mongolia in 2004 to that in 2009?
Your answer should be very brief. 1.21. What is the ratio of the Area of land (hectares per person) of Netherlands in 2004 to that in 2009?
Give a very brief answer. 1.09. What is the ratio of the Area of land (hectares per person) of Central Europe in 2005 to that in 2006?
Provide a succinct answer. 0.99. What is the ratio of the Area of land (hectares per person) of Mongolia in 2005 to that in 2006?
Your answer should be very brief. 1.01. What is the ratio of the Area of land (hectares per person) of Netherlands in 2005 to that in 2006?
Provide a short and direct response. 1.04. What is the ratio of the Area of land (hectares per person) in Central Europe in 2005 to that in 2007?
Your answer should be very brief. 1.01. What is the ratio of the Area of land (hectares per person) in Mongolia in 2005 to that in 2007?
Your answer should be very brief. 1.01. What is the ratio of the Area of land (hectares per person) of Netherlands in 2005 to that in 2007?
Offer a terse response. 1.05. What is the ratio of the Area of land (hectares per person) in Mongolia in 2005 to that in 2008?
Provide a succinct answer. 0.87. What is the ratio of the Area of land (hectares per person) of Netherlands in 2005 to that in 2008?
Make the answer very short. 1.05. What is the ratio of the Area of land (hectares per person) in Mongolia in 2005 to that in 2009?
Your answer should be very brief. 1.18. What is the ratio of the Area of land (hectares per person) in Netherlands in 2005 to that in 2009?
Your answer should be compact. 1.07. What is the ratio of the Area of land (hectares per person) of Central Europe in 2006 to that in 2007?
Offer a terse response. 1.02. What is the ratio of the Area of land (hectares per person) of Netherlands in 2006 to that in 2007?
Provide a succinct answer. 1.01. What is the ratio of the Area of land (hectares per person) of Central Europe in 2006 to that in 2008?
Keep it short and to the point. 1.01. What is the ratio of the Area of land (hectares per person) of Mongolia in 2006 to that in 2008?
Your answer should be very brief. 0.86. What is the ratio of the Area of land (hectares per person) in Netherlands in 2006 to that in 2008?
Provide a succinct answer. 1.01. What is the ratio of the Area of land (hectares per person) of Mongolia in 2006 to that in 2009?
Your answer should be compact. 1.17. What is the ratio of the Area of land (hectares per person) of Netherlands in 2006 to that in 2009?
Ensure brevity in your answer.  1.03. What is the ratio of the Area of land (hectares per person) of Mongolia in 2007 to that in 2008?
Offer a terse response. 0.85. What is the ratio of the Area of land (hectares per person) in Central Europe in 2007 to that in 2009?
Give a very brief answer. 0.98. What is the ratio of the Area of land (hectares per person) in Mongolia in 2007 to that in 2009?
Provide a short and direct response. 1.16. What is the ratio of the Area of land (hectares per person) of Mongolia in 2008 to that in 2009?
Provide a succinct answer. 1.36. What is the ratio of the Area of land (hectares per person) of Netherlands in 2008 to that in 2009?
Make the answer very short. 1.02. What is the difference between the highest and the second highest Area of land (hectares per person) of Central Europe?
Keep it short and to the point. 0. What is the difference between the highest and the second highest Area of land (hectares per person) in Mongolia?
Provide a short and direct response. 0.01. What is the difference between the highest and the second highest Area of land (hectares per person) in Netherlands?
Your response must be concise. 0. What is the difference between the highest and the lowest Area of land (hectares per person) in Central Europe?
Provide a short and direct response. 0.01. What is the difference between the highest and the lowest Area of land (hectares per person) in Mongolia?
Provide a succinct answer. 0.08. What is the difference between the highest and the lowest Area of land (hectares per person) of Netherlands?
Offer a terse response. 0.01. 